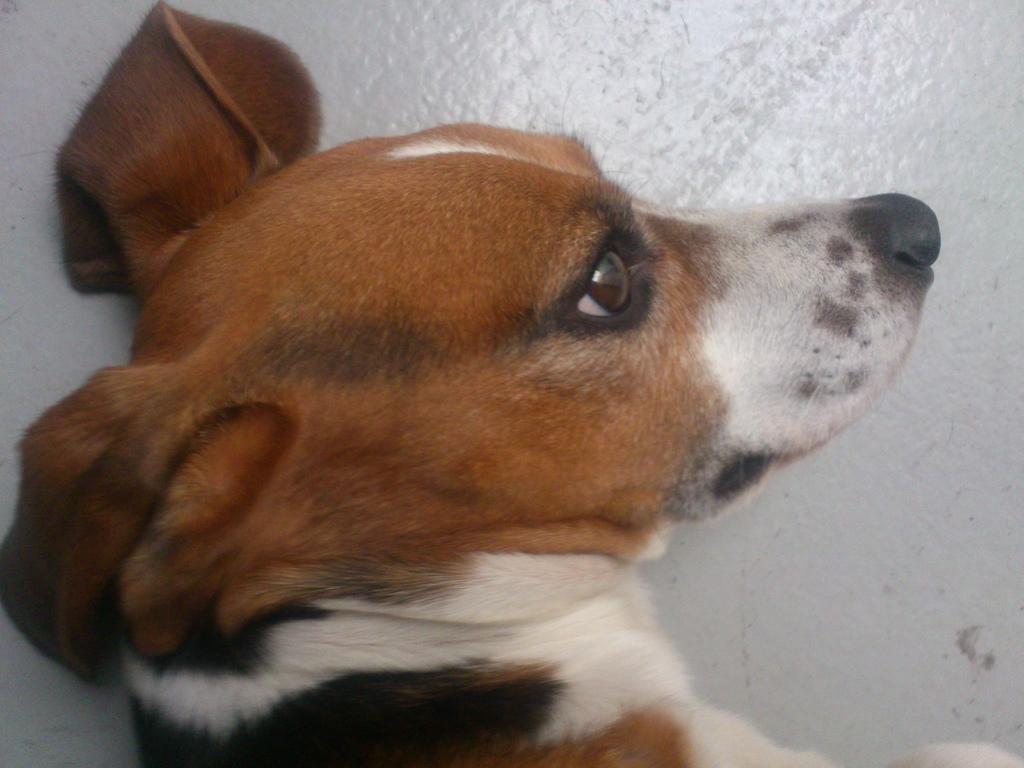In one or two sentences, can you explain what this image depicts? In this picture we can see a dog lying on a white surface. 